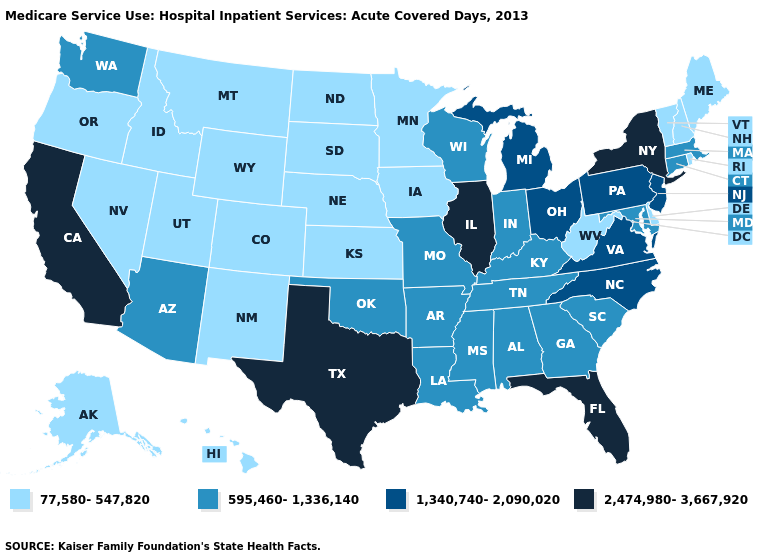Does the first symbol in the legend represent the smallest category?
Short answer required. Yes. What is the lowest value in the South?
Give a very brief answer. 77,580-547,820. Does Louisiana have the highest value in the USA?
Be succinct. No. Name the states that have a value in the range 77,580-547,820?
Quick response, please. Alaska, Colorado, Delaware, Hawaii, Idaho, Iowa, Kansas, Maine, Minnesota, Montana, Nebraska, Nevada, New Hampshire, New Mexico, North Dakota, Oregon, Rhode Island, South Dakota, Utah, Vermont, West Virginia, Wyoming. What is the value of Kansas?
Keep it brief. 77,580-547,820. Name the states that have a value in the range 2,474,980-3,667,920?
Concise answer only. California, Florida, Illinois, New York, Texas. Name the states that have a value in the range 2,474,980-3,667,920?
Write a very short answer. California, Florida, Illinois, New York, Texas. Name the states that have a value in the range 77,580-547,820?
Write a very short answer. Alaska, Colorado, Delaware, Hawaii, Idaho, Iowa, Kansas, Maine, Minnesota, Montana, Nebraska, Nevada, New Hampshire, New Mexico, North Dakota, Oregon, Rhode Island, South Dakota, Utah, Vermont, West Virginia, Wyoming. Among the states that border Louisiana , does Texas have the lowest value?
Give a very brief answer. No. Does the map have missing data?
Quick response, please. No. Does Wisconsin have the lowest value in the USA?
Concise answer only. No. Which states hav the highest value in the South?
Be succinct. Florida, Texas. What is the value of West Virginia?
Concise answer only. 77,580-547,820. What is the value of Arizona?
Quick response, please. 595,460-1,336,140. 